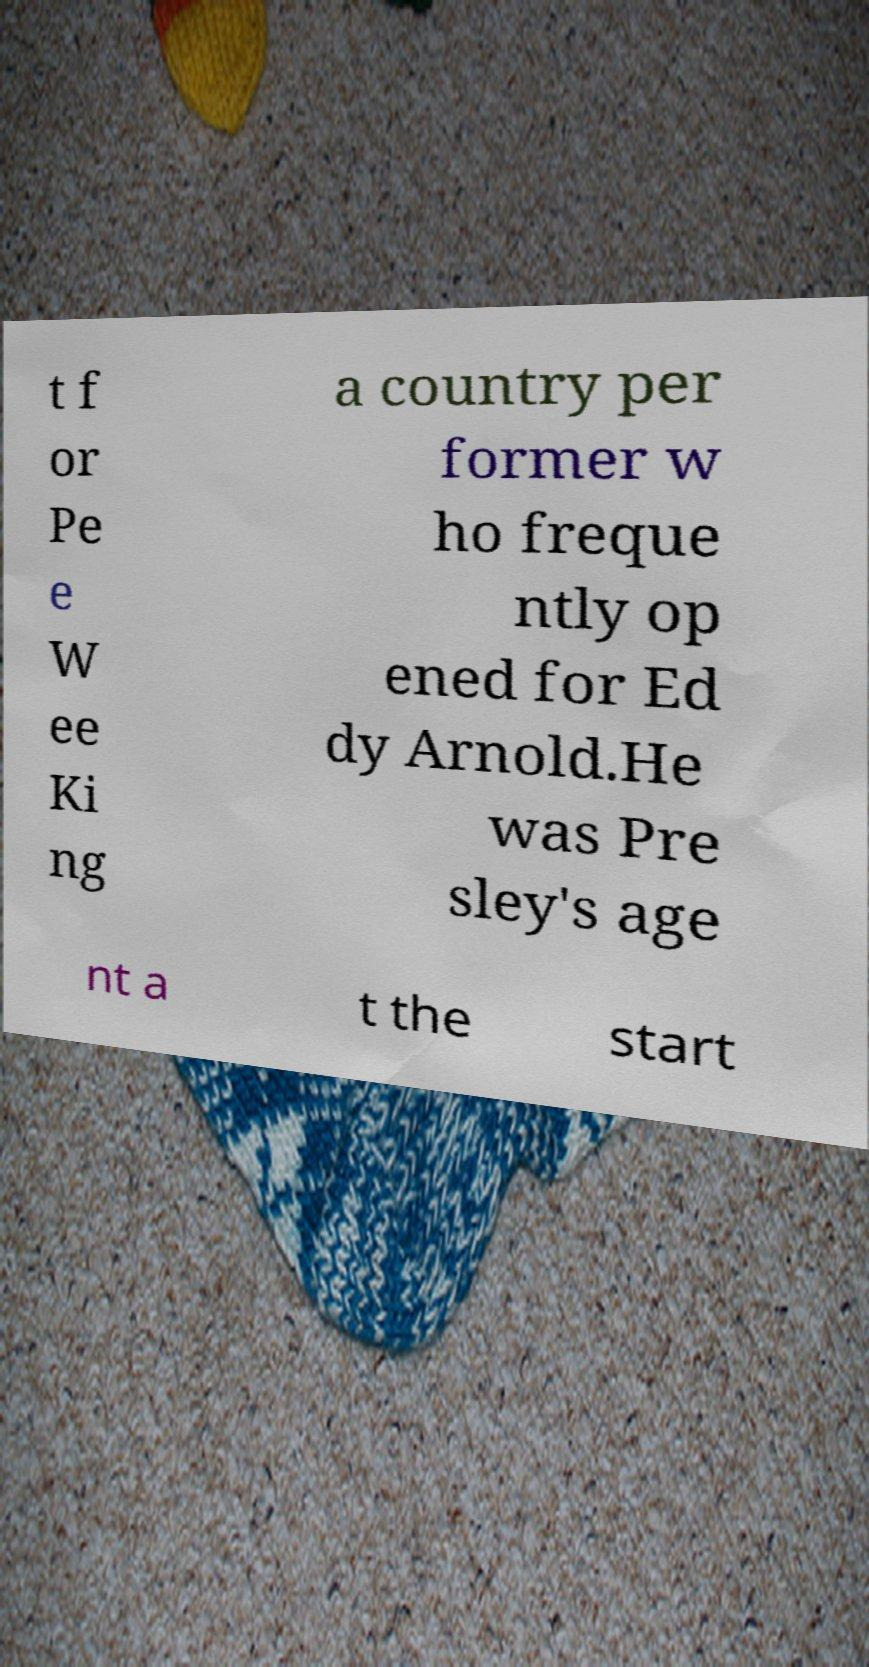Can you accurately transcribe the text from the provided image for me? t f or Pe e W ee Ki ng a country per former w ho freque ntly op ened for Ed dy Arnold.He was Pre sley's age nt a t the start 